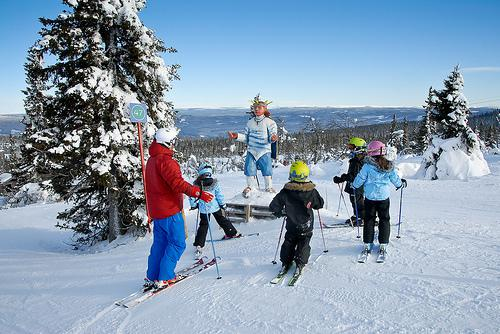Question: how many people are in the photo?
Choices:
A. Five.
B. Four.
C. One.
D. Two.
Answer with the letter. Answer: A Question: where was this photo taken?
Choices:
A. At the farm.
B. In Ireland.
C. In Idaho.
D. On a ski mountain.
Answer with the letter. Answer: D Question: why was this photo taken?
Choices:
A. For a travel magazine.
B. For a photo album.
C. For posterity.
D. To show skiers.
Answer with the letter. Answer: D Question: what are the people looking at?
Choices:
A. A statue.
B. A painting.
C. A fountain.
D. A book.
Answer with the letter. Answer: A 